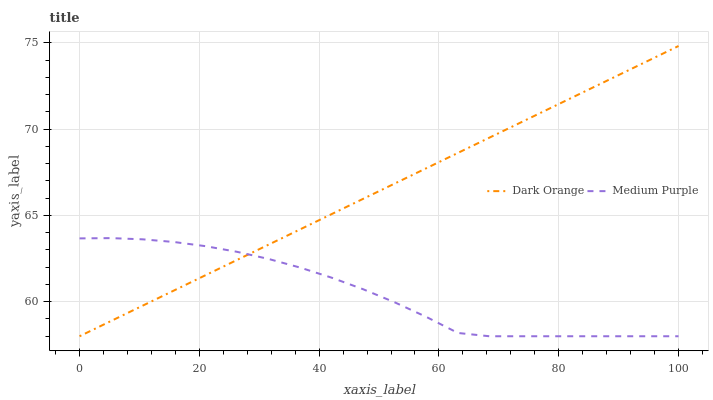Does Medium Purple have the minimum area under the curve?
Answer yes or no. Yes. Does Dark Orange have the maximum area under the curve?
Answer yes or no. Yes. Does Dark Orange have the minimum area under the curve?
Answer yes or no. No. Is Dark Orange the smoothest?
Answer yes or no. Yes. Is Medium Purple the roughest?
Answer yes or no. Yes. Is Dark Orange the roughest?
Answer yes or no. No. Does Dark Orange have the highest value?
Answer yes or no. Yes. Does Dark Orange intersect Medium Purple?
Answer yes or no. Yes. Is Dark Orange less than Medium Purple?
Answer yes or no. No. Is Dark Orange greater than Medium Purple?
Answer yes or no. No. 